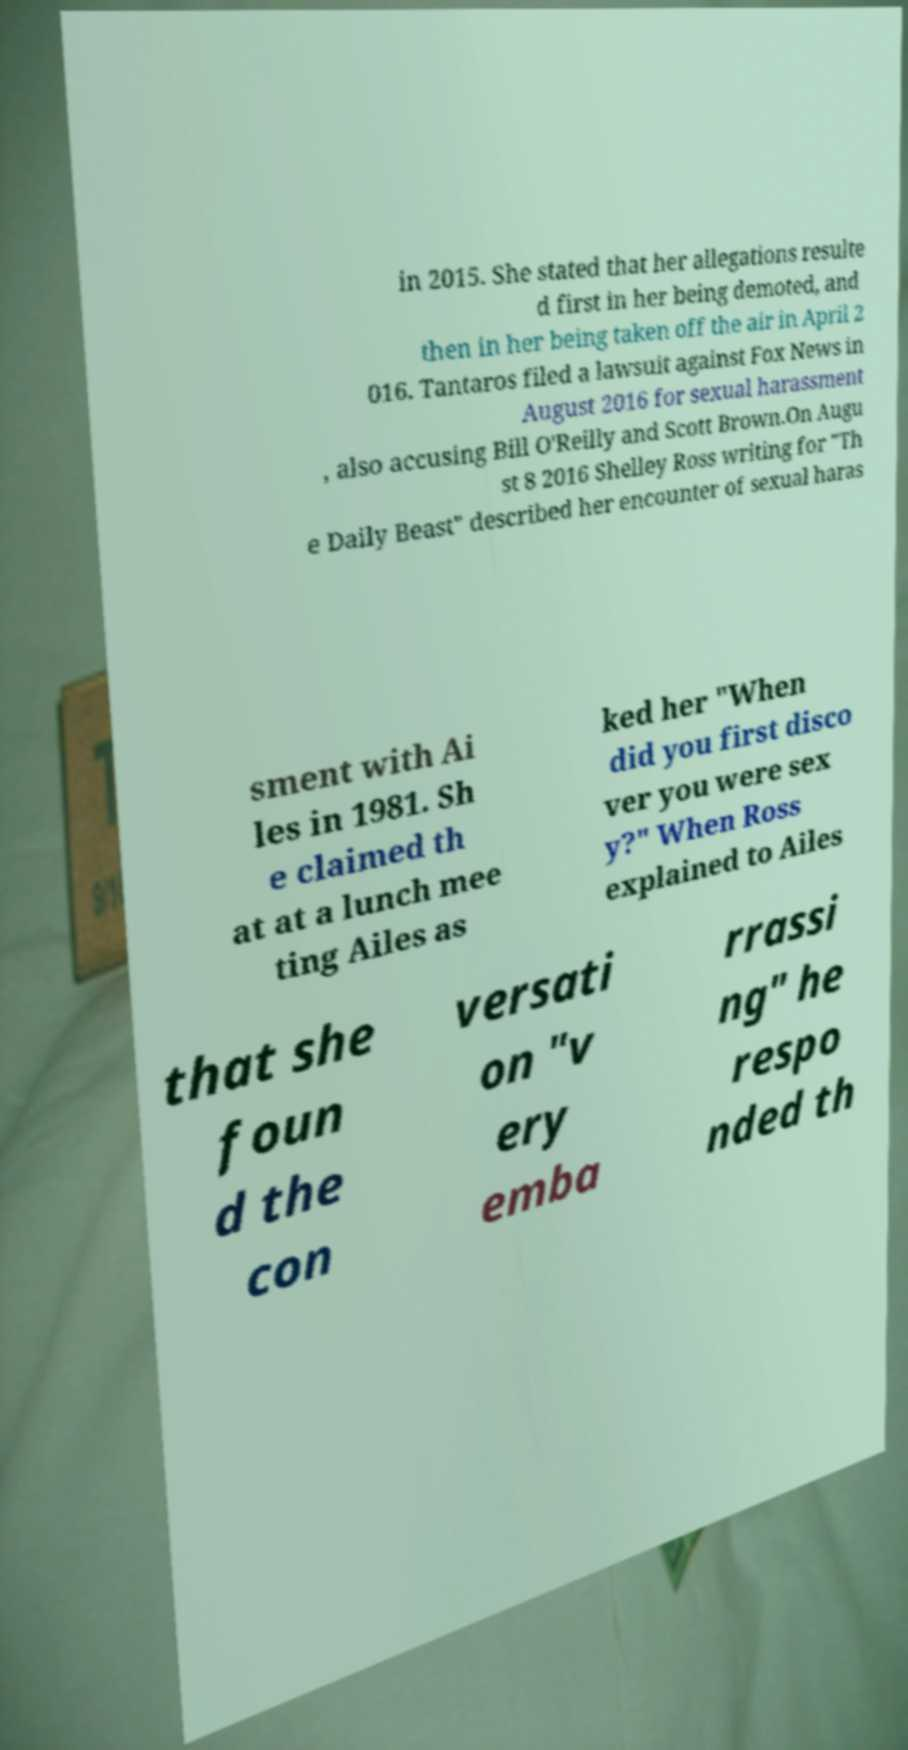Please identify and transcribe the text found in this image. in 2015. She stated that her allegations resulte d first in her being demoted, and then in her being taken off the air in April 2 016. Tantaros filed a lawsuit against Fox News in August 2016 for sexual harassment , also accusing Bill O'Reilly and Scott Brown.On Augu st 8 2016 Shelley Ross writing for "Th e Daily Beast" described her encounter of sexual haras sment with Ai les in 1981. Sh e claimed th at at a lunch mee ting Ailes as ked her "When did you first disco ver you were sex y?" When Ross explained to Ailes that she foun d the con versati on "v ery emba rrassi ng" he respo nded th 